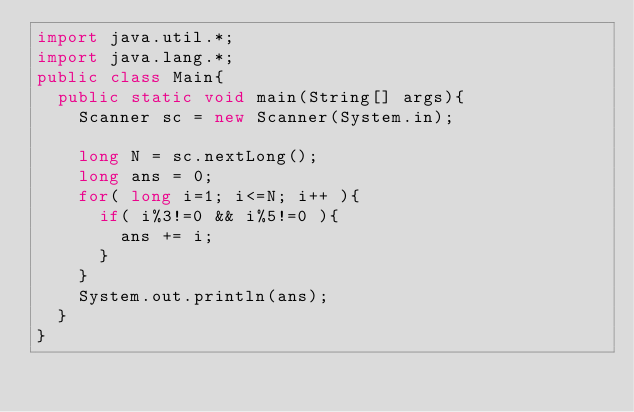Convert code to text. <code><loc_0><loc_0><loc_500><loc_500><_Java_>import java.util.*;
import java.lang.*;
public class Main{
	public static void main(String[] args){
		Scanner sc = new Scanner(System.in);

		long N = sc.nextLong();
		long ans = 0;
		for( long i=1; i<=N; i++ ){
			if( i%3!=0 && i%5!=0 ){
				ans += i;
			}
		}
		System.out.println(ans);
	}
}</code> 